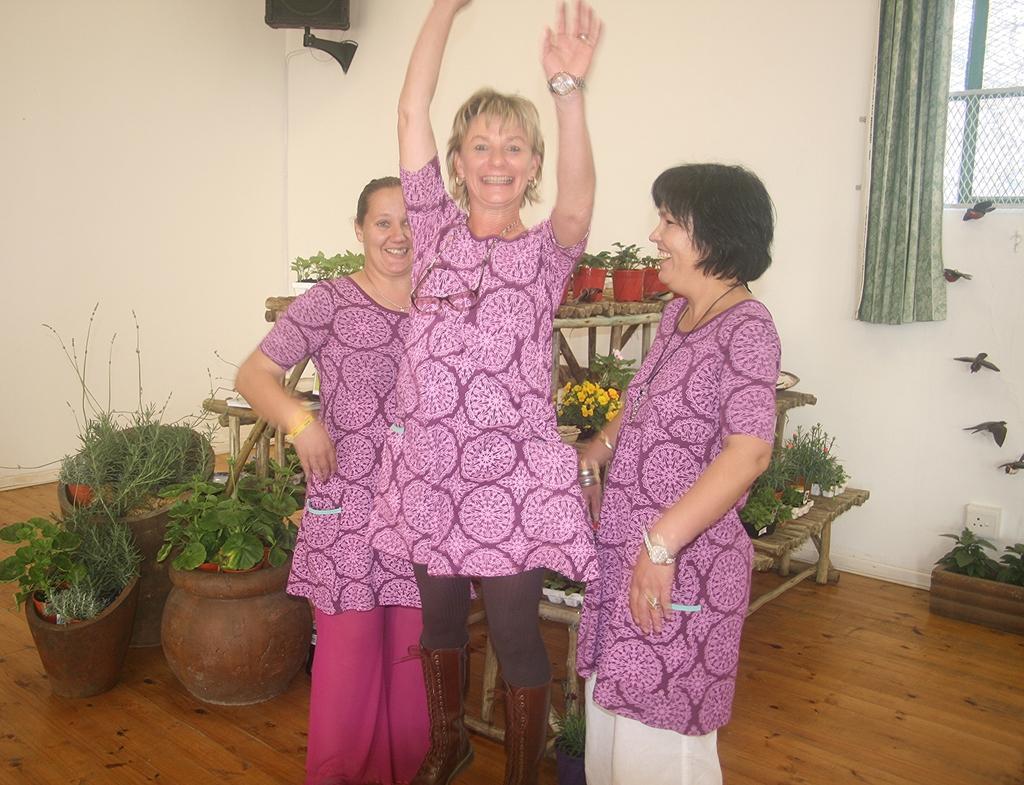In one or two sentences, can you explain what this image depicts? In this picture I can see three women's are standing behind we can see some potted plants and also I can see window to the wall. 